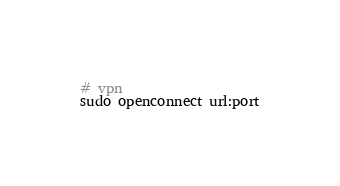<code> <loc_0><loc_0><loc_500><loc_500><_Bash_># vpn
sudo openconnect url:port
</code> 